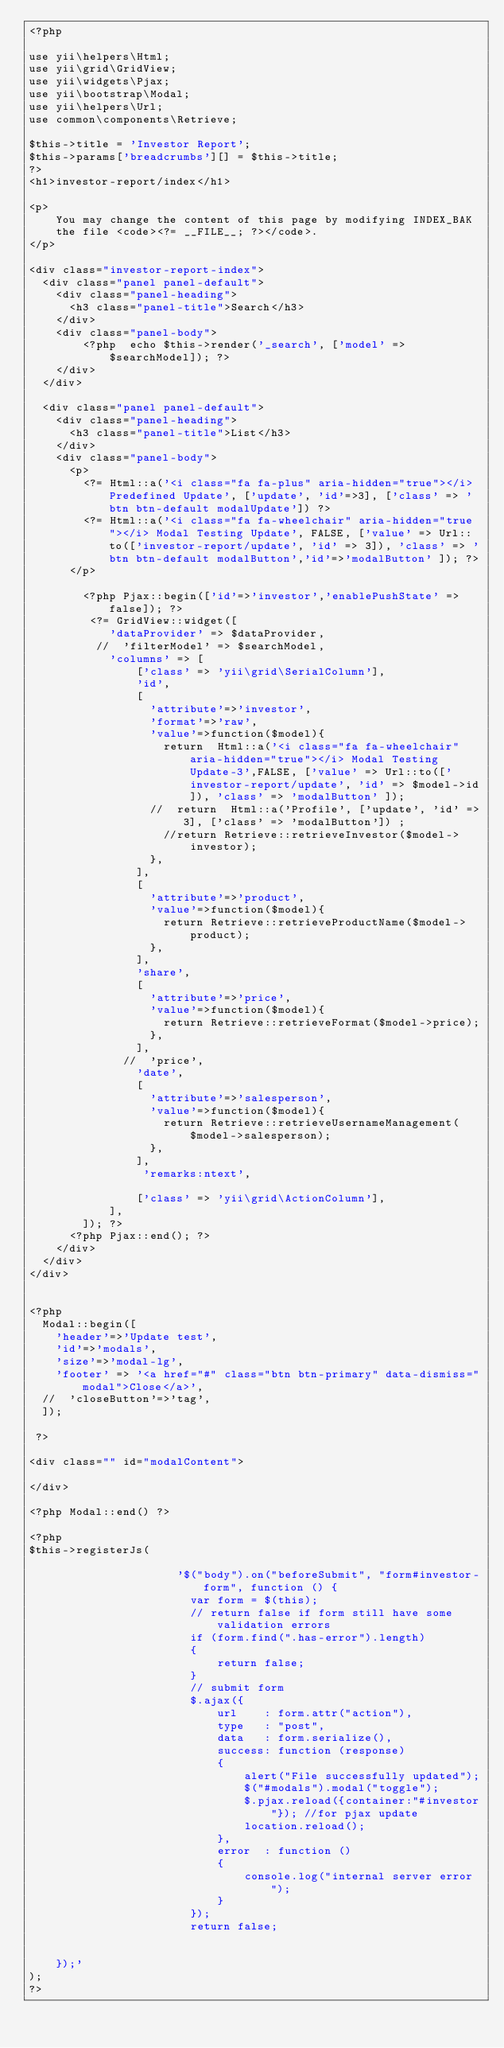<code> <loc_0><loc_0><loc_500><loc_500><_PHP_><?php

use yii\helpers\Html;
use yii\grid\GridView;
use yii\widgets\Pjax;
use yii\bootstrap\Modal;
use yii\helpers\Url;
use common\components\Retrieve;

$this->title = 'Investor Report';
$this->params['breadcrumbs'][] = $this->title;
?>
<h1>investor-report/index</h1>

<p>
    You may change the content of this page by modifying INDEX_BAK
    the file <code><?= __FILE__; ?></code>.
</p>

<div class="investor-report-index">
  <div class="panel panel-default">
    <div class="panel-heading">
      <h3 class="panel-title">Search</h3>
    </div>
    <div class="panel-body">
        <?php  echo $this->render('_search', ['model' => $searchModel]); ?>
    </div>
  </div>

  <div class="panel panel-default">
    <div class="panel-heading">
      <h3 class="panel-title">List</h3>
    </div>
    <div class="panel-body">
      <p>
        <?= Html::a('<i class="fa fa-plus" aria-hidden="true"></i> Predefined Update', ['update', 'id'=>3], ['class' => 'btn btn-default modalUpdate']) ?>
        <?= Html::a('<i class="fa fa-wheelchair" aria-hidden="true"></i> Modal Testing Update', FALSE, ['value' => Url::to(['investor-report/update', 'id' => 3]), 'class' => 'btn btn-default modalButton','id'=>'modalButton' ]); ?>
      </p>

        <?php Pjax::begin(['id'=>'investor','enablePushState' => false]); ?>
         <?= GridView::widget([
            'dataProvider' => $dataProvider,
          //  'filterModel' => $searchModel,
            'columns' => [
                ['class' => 'yii\grid\SerialColumn'],
                'id',
                [
                  'attribute'=>'investor',
                  'format'=>'raw',
                  'value'=>function($model){
                    return  Html::a('<i class="fa fa-wheelchair" aria-hidden="true"></i> Modal Testing Update-3',FALSE, ['value' => Url::to(['investor-report/update', 'id' => $model->id]), 'class' => 'modalButton' ]);
                  //  return  Html::a('Profile', ['update', 'id' => 3], ['class' => 'modalButton']) ;
                    //return Retrieve::retrieveInvestor($model->investor);
                  },
                ],
                [
                  'attribute'=>'product',
                  'value'=>function($model){
                    return Retrieve::retrieveProductName($model->product);
                  },
                ],
                'share',
                [
                  'attribute'=>'price',
                  'value'=>function($model){
                    return Retrieve::retrieveFormat($model->price);
                  },
                ],
              //  'price',
                'date',
                [
                  'attribute'=>'salesperson',
                  'value'=>function($model){
                    return Retrieve::retrieveUsernameManagement($model->salesperson);
                  },
                ],
                 'remarks:ntext',

                ['class' => 'yii\grid\ActionColumn'],
            ],
        ]); ?>
      <?php Pjax::end(); ?>
    </div>
  </div>
</div>


<?php
  Modal::begin([
    'header'=>'Update test',
    'id'=>'modals',
    'size'=>'modal-lg',
    'footer' => '<a href="#" class="btn btn-primary" data-dismiss="modal">Close</a>',
  //  'closeButton'=>'tag',
  ]);

 ?>

<div class="" id="modalContent">

</div>

<?php Modal::end() ?>

<?php
$this->registerJs(

                      '$("body").on("beforeSubmit", "form#investor-form", function () {
                        var form = $(this);
                        // return false if form still have some validation errors
                        if (form.find(".has-error").length)
                        {
                            return false;
                        }
                        // submit form
                        $.ajax({
                            url    : form.attr("action"),
                            type   : "post",
                            data   : form.serialize(),
                            success: function (response)
                            {
                                alert("File successfully updated");
                                $("#modals").modal("toggle");
                                $.pjax.reload({container:"#investor"}); //for pjax update
                                location.reload();
                            },
                            error  : function ()
                            {
                                console.log("internal server error");
                            }
                        });
                        return false;


    });'
);
?>
</code> 